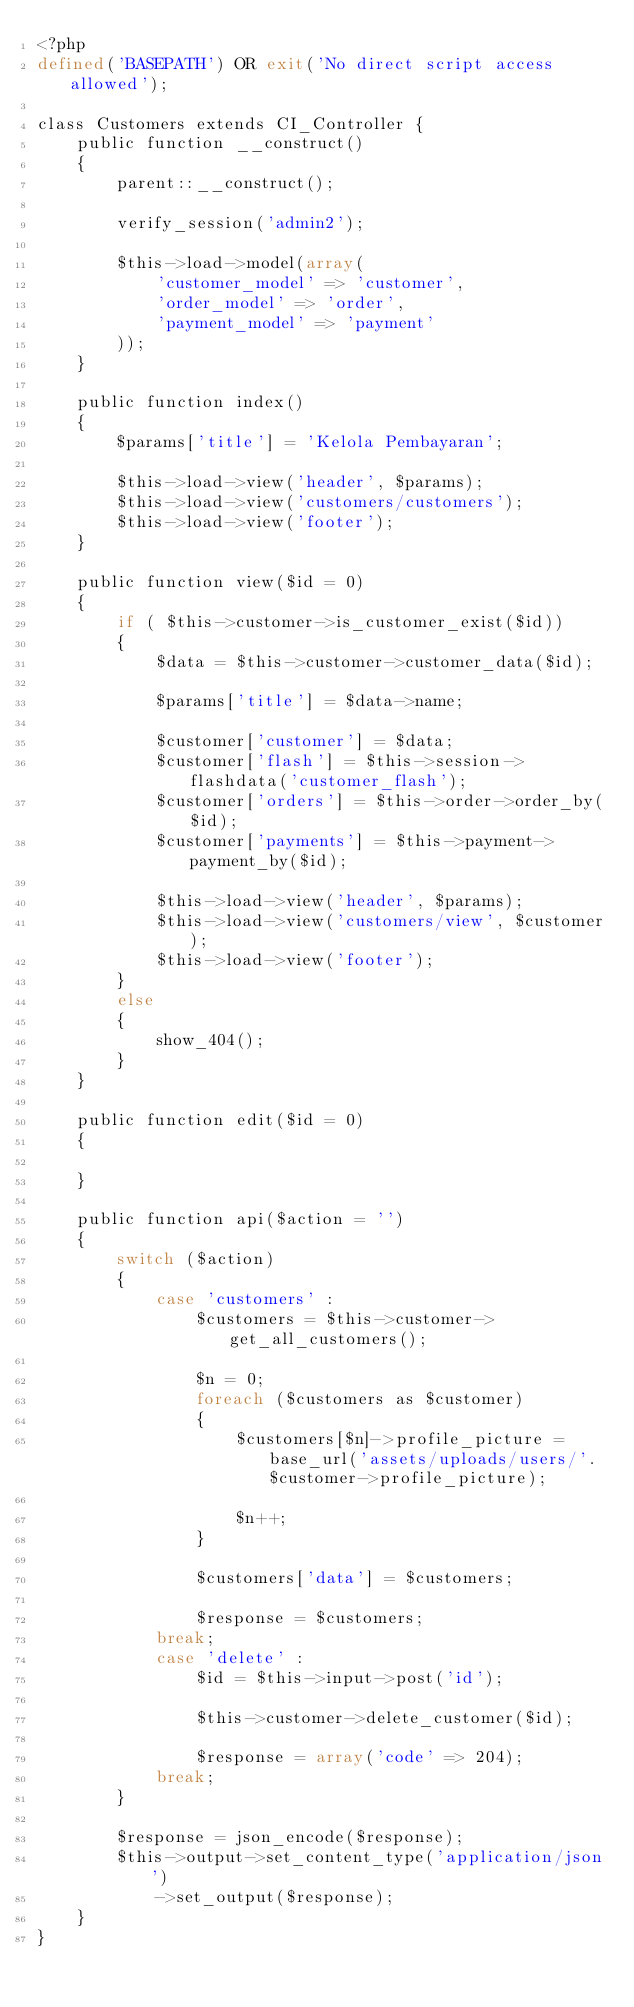<code> <loc_0><loc_0><loc_500><loc_500><_PHP_><?php
defined('BASEPATH') OR exit('No direct script access allowed');

class Customers extends CI_Controller {
    public function __construct()
    {
        parent::__construct();

        verify_session('admin2');

        $this->load->model(array(
            'customer_model' => 'customer',
            'order_model' => 'order',
            'payment_model' => 'payment'
        ));
    }

    public function index()
    {
        $params['title'] = 'Kelola Pembayaran';

        $this->load->view('header', $params);
        $this->load->view('customers/customers');
        $this->load->view('footer');
    }

    public function view($id = 0)
    {
        if ( $this->customer->is_customer_exist($id))
        {
            $data = $this->customer->customer_data($id);

            $params['title'] = $data->name;

            $customer['customer'] = $data;
            $customer['flash'] = $this->session->flashdata('customer_flash');
            $customer['orders'] = $this->order->order_by($id);
            $customer['payments'] = $this->payment->payment_by($id);

            $this->load->view('header', $params);
            $this->load->view('customers/view', $customer);
            $this->load->view('footer');
        }
        else
        {
            show_404();
        }
    }

    public function edit($id = 0)
    {

    }

    public function api($action = '')
    {
        switch ($action)
        {
            case 'customers' :
                $customers = $this->customer->get_all_customers();

                $n = 0;
                foreach ($customers as $customer)
                {
                    $customers[$n]->profile_picture = base_url('assets/uploads/users/'. $customer->profile_picture);

                    $n++;
                }

                $customers['data'] = $customers;

                $response = $customers;
            break;
            case 'delete' :
                $id = $this->input->post('id');

                $this->customer->delete_customer($id);

                $response = array('code' => 204);
            break;
        }

        $response = json_encode($response);
        $this->output->set_content_type('application/json')
            ->set_output($response);
    }
}
</code> 